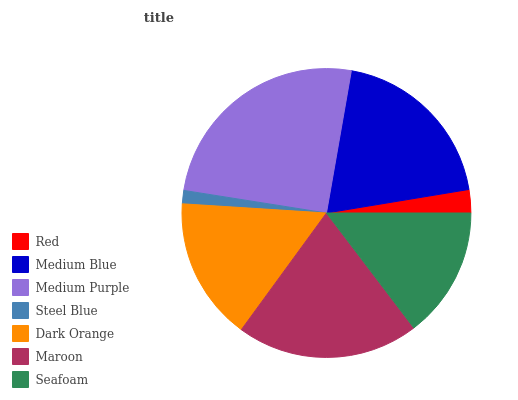Is Steel Blue the minimum?
Answer yes or no. Yes. Is Medium Purple the maximum?
Answer yes or no. Yes. Is Medium Blue the minimum?
Answer yes or no. No. Is Medium Blue the maximum?
Answer yes or no. No. Is Medium Blue greater than Red?
Answer yes or no. Yes. Is Red less than Medium Blue?
Answer yes or no. Yes. Is Red greater than Medium Blue?
Answer yes or no. No. Is Medium Blue less than Red?
Answer yes or no. No. Is Dark Orange the high median?
Answer yes or no. Yes. Is Dark Orange the low median?
Answer yes or no. Yes. Is Seafoam the high median?
Answer yes or no. No. Is Maroon the low median?
Answer yes or no. No. 